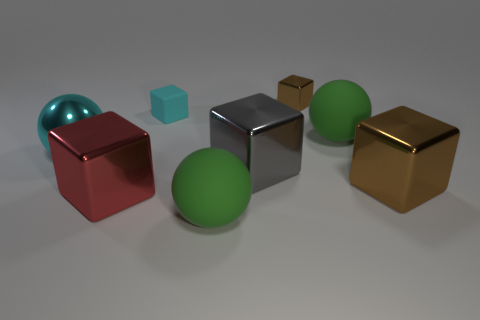There is a brown block that is behind the large brown shiny thing; what material is it?
Make the answer very short. Metal. What number of gray metallic blocks are in front of the large metallic thing that is to the right of the gray cube?
Give a very brief answer. 0. What number of other big red things have the same shape as the large red object?
Keep it short and to the point. 0. How many big purple rubber spheres are there?
Give a very brief answer. 0. There is a large rubber thing on the right side of the tiny metal cube; what is its color?
Provide a short and direct response. Green. There is a large rubber thing in front of the big green thing that is behind the big shiny sphere; what color is it?
Your answer should be very brief. Green. What is the color of the other cube that is the same size as the matte block?
Offer a very short reply. Brown. How many cubes are in front of the gray shiny block and behind the tiny rubber cube?
Make the answer very short. 0. What is the shape of the large shiny object that is the same color as the small matte cube?
Provide a short and direct response. Sphere. There is a big ball that is both to the left of the small shiny object and to the right of the rubber block; what is its material?
Ensure brevity in your answer.  Rubber. 